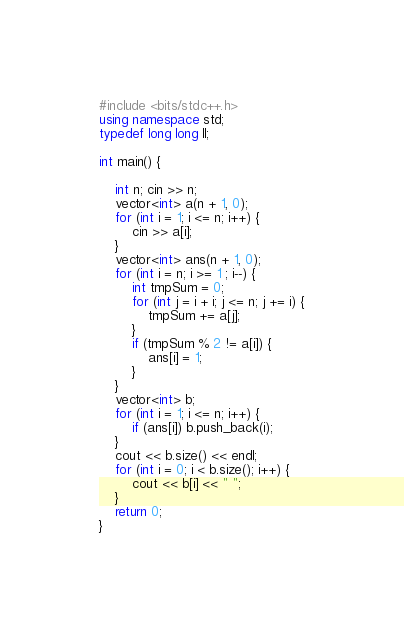Convert code to text. <code><loc_0><loc_0><loc_500><loc_500><_C++_>#include <bits/stdc++.h>
using namespace std;
typedef long long ll;

int main() {

	int n; cin >> n;
	vector<int> a(n + 1, 0);
	for (int i = 1; i <= n; i++) {
		cin >> a[i];
	}
	vector<int> ans(n + 1, 0);
	for (int i = n; i >= 1 ; i--) {
		int tmpSum = 0;
		for (int j = i + i; j <= n; j += i) {
			tmpSum += a[j];
		}
		if (tmpSum % 2 != a[i]) {
			ans[i] = 1;
		}
	}
	vector<int> b;
	for (int i = 1; i <= n; i++) {
		if (ans[i]) b.push_back(i);
	}
	cout << b.size() << endl;
	for (int i = 0; i < b.size(); i++) {
		cout << b[i] << " ";
	}
	return 0;
}</code> 